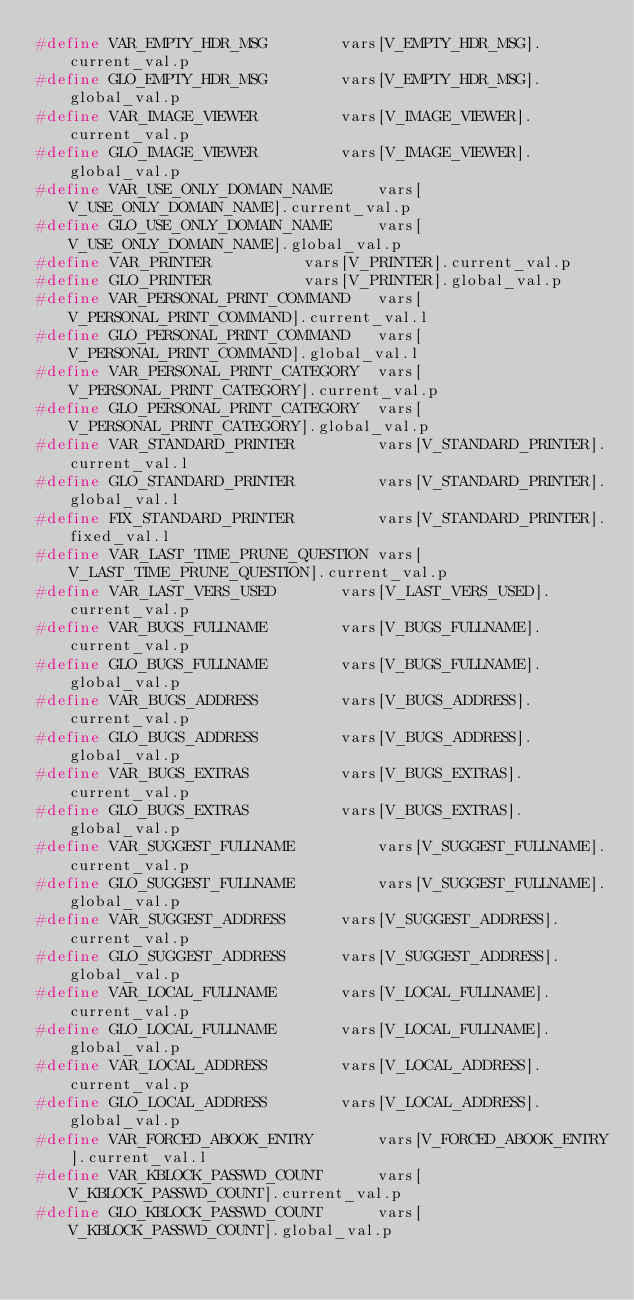<code> <loc_0><loc_0><loc_500><loc_500><_C_>#define VAR_EMPTY_HDR_MSG	     vars[V_EMPTY_HDR_MSG].current_val.p
#define GLO_EMPTY_HDR_MSG	     vars[V_EMPTY_HDR_MSG].global_val.p
#define VAR_IMAGE_VIEWER	     vars[V_IMAGE_VIEWER].current_val.p
#define GLO_IMAGE_VIEWER	     vars[V_IMAGE_VIEWER].global_val.p
#define VAR_USE_ONLY_DOMAIN_NAME     vars[V_USE_ONLY_DOMAIN_NAME].current_val.p
#define GLO_USE_ONLY_DOMAIN_NAME     vars[V_USE_ONLY_DOMAIN_NAME].global_val.p
#define VAR_PRINTER		     vars[V_PRINTER].current_val.p
#define GLO_PRINTER		     vars[V_PRINTER].global_val.p
#define VAR_PERSONAL_PRINT_COMMAND   vars[V_PERSONAL_PRINT_COMMAND].current_val.l
#define GLO_PERSONAL_PRINT_COMMAND   vars[V_PERSONAL_PRINT_COMMAND].global_val.l
#define VAR_PERSONAL_PRINT_CATEGORY  vars[V_PERSONAL_PRINT_CATEGORY].current_val.p
#define GLO_PERSONAL_PRINT_CATEGORY  vars[V_PERSONAL_PRINT_CATEGORY].global_val.p
#define VAR_STANDARD_PRINTER	     vars[V_STANDARD_PRINTER].current_val.l
#define GLO_STANDARD_PRINTER	     vars[V_STANDARD_PRINTER].global_val.l
#define FIX_STANDARD_PRINTER	     vars[V_STANDARD_PRINTER].fixed_val.l
#define VAR_LAST_TIME_PRUNE_QUESTION vars[V_LAST_TIME_PRUNE_QUESTION].current_val.p
#define VAR_LAST_VERS_USED	     vars[V_LAST_VERS_USED].current_val.p
#define VAR_BUGS_FULLNAME	     vars[V_BUGS_FULLNAME].current_val.p
#define GLO_BUGS_FULLNAME	     vars[V_BUGS_FULLNAME].global_val.p
#define VAR_BUGS_ADDRESS	     vars[V_BUGS_ADDRESS].current_val.p
#define GLO_BUGS_ADDRESS	     vars[V_BUGS_ADDRESS].global_val.p
#define VAR_BUGS_EXTRAS		     vars[V_BUGS_EXTRAS].current_val.p
#define GLO_BUGS_EXTRAS		     vars[V_BUGS_EXTRAS].global_val.p
#define VAR_SUGGEST_FULLNAME	     vars[V_SUGGEST_FULLNAME].current_val.p
#define GLO_SUGGEST_FULLNAME	     vars[V_SUGGEST_FULLNAME].global_val.p
#define VAR_SUGGEST_ADDRESS	     vars[V_SUGGEST_ADDRESS].current_val.p
#define GLO_SUGGEST_ADDRESS	     vars[V_SUGGEST_ADDRESS].global_val.p
#define VAR_LOCAL_FULLNAME	     vars[V_LOCAL_FULLNAME].current_val.p
#define GLO_LOCAL_FULLNAME	     vars[V_LOCAL_FULLNAME].global_val.p
#define VAR_LOCAL_ADDRESS	     vars[V_LOCAL_ADDRESS].current_val.p
#define GLO_LOCAL_ADDRESS	     vars[V_LOCAL_ADDRESS].global_val.p
#define VAR_FORCED_ABOOK_ENTRY	     vars[V_FORCED_ABOOK_ENTRY].current_val.l
#define VAR_KBLOCK_PASSWD_COUNT	     vars[V_KBLOCK_PASSWD_COUNT].current_val.p
#define GLO_KBLOCK_PASSWD_COUNT	     vars[V_KBLOCK_PASSWD_COUNT].global_val.p</code> 